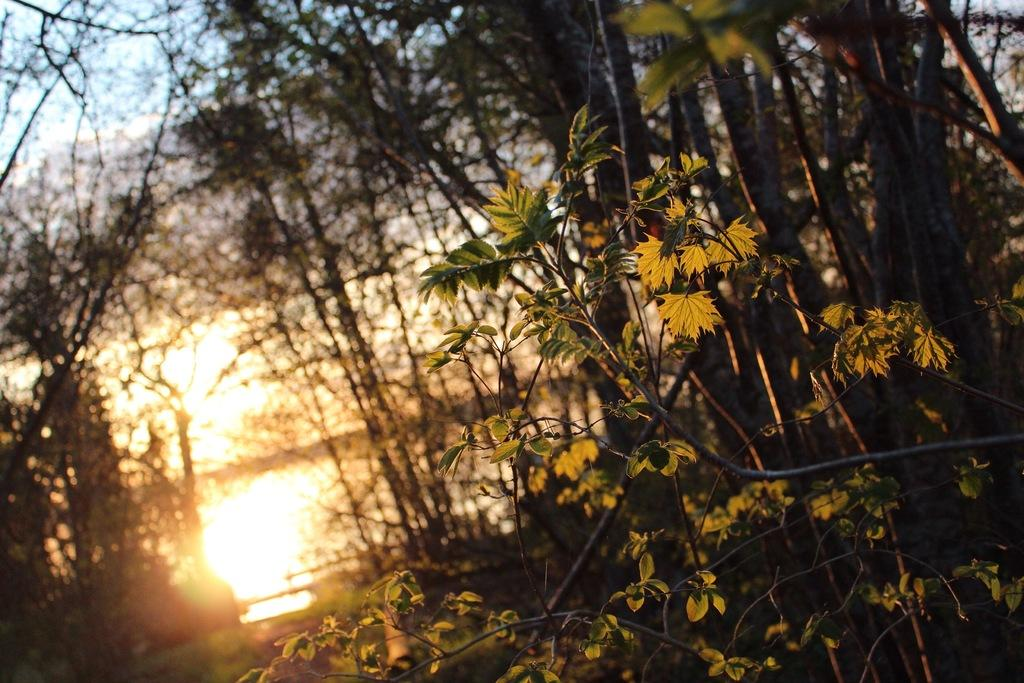What type of vegetation can be seen in the image? There are trees in the image. What part of the natural environment is visible in the image? The sky is visible in the background of the image. What type of skirt can be seen hanging from the tree in the image? There is no skirt present in the image; it only features trees and the sky. 